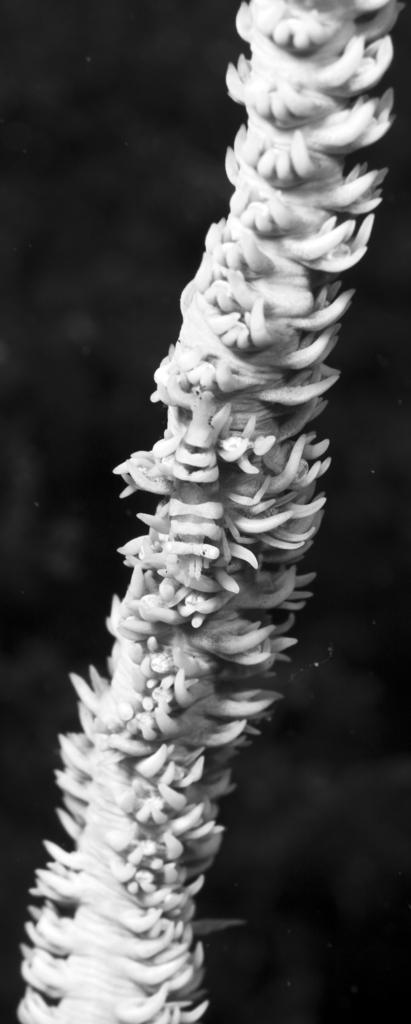What is the main subject of the image? There is an object in the image. Can you describe the background of the image? The background of the image is dark. What type of request can be seen in the image? There is no request present in the image; it only contains an object and a dark background. What type of coal is visible in the image? There is no coal present in the image. 